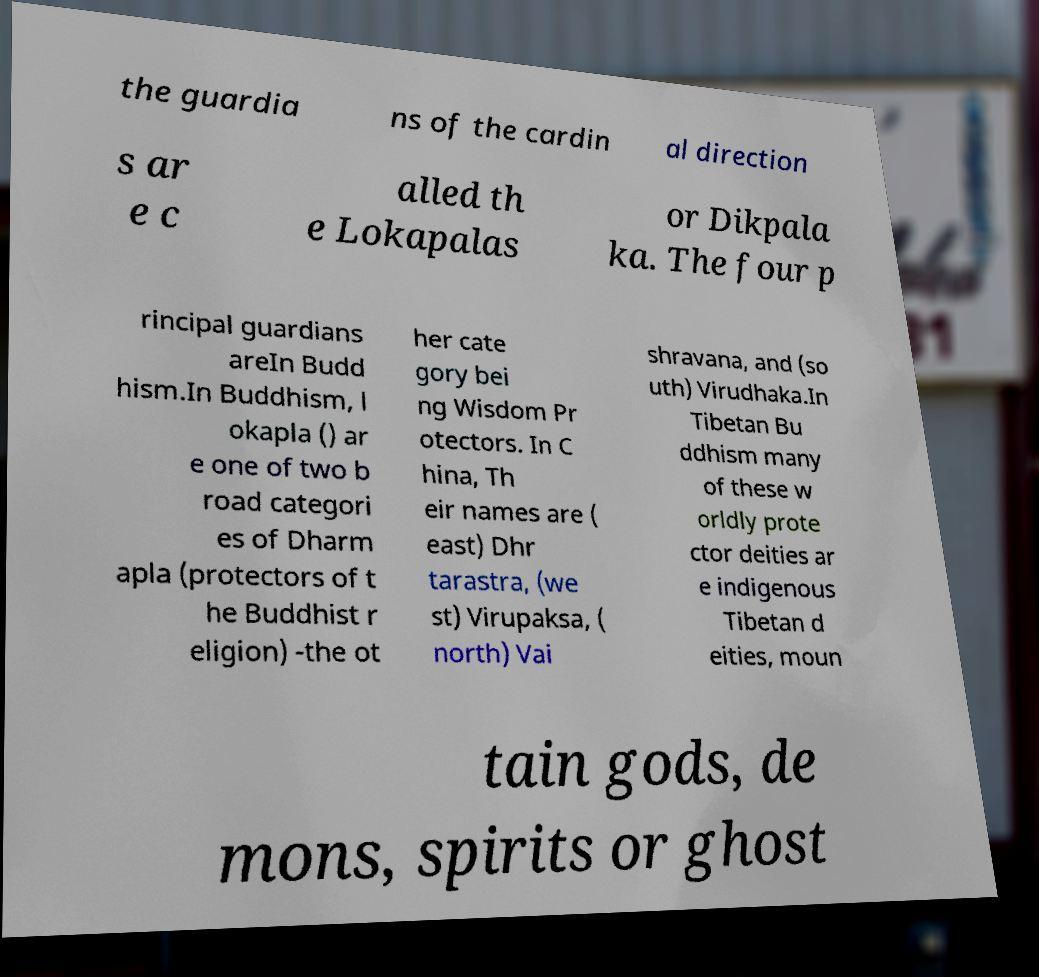Please identify and transcribe the text found in this image. the guardia ns of the cardin al direction s ar e c alled th e Lokapalas or Dikpala ka. The four p rincipal guardians areIn Budd hism.In Buddhism, l okapla () ar e one of two b road categori es of Dharm apla (protectors of t he Buddhist r eligion) -the ot her cate gory bei ng Wisdom Pr otectors. In C hina, Th eir names are ( east) Dhr tarastra, (we st) Virupaksa, ( north) Vai shravana, and (so uth) Virudhaka.In Tibetan Bu ddhism many of these w orldly prote ctor deities ar e indigenous Tibetan d eities, moun tain gods, de mons, spirits or ghost 